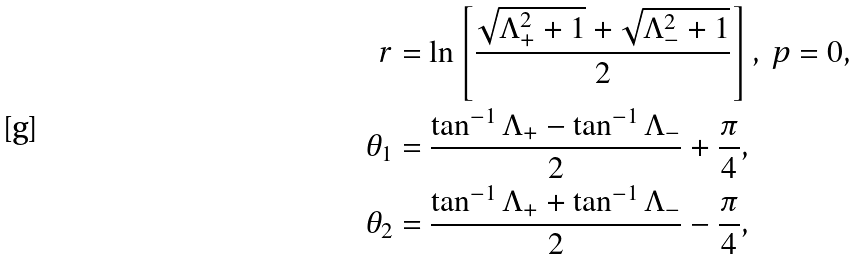<formula> <loc_0><loc_0><loc_500><loc_500>r & = \ln \left [ \frac { \sqrt { \Lambda _ { + } ^ { 2 } + 1 } + \sqrt { \Lambda _ { - } ^ { 2 } + 1 } } { 2 } \right ] , \ p = 0 , \\ \theta _ { 1 } & = \frac { \tan ^ { - 1 } \Lambda _ { + } - \tan ^ { - 1 } \Lambda _ { - } } { 2 } + \frac { \pi } { 4 } , \\ \theta _ { 2 } & = \frac { \tan ^ { - 1 } \Lambda _ { + } + \tan ^ { - 1 } \Lambda _ { - } } { 2 } - \frac { \pi } { 4 } ,</formula> 